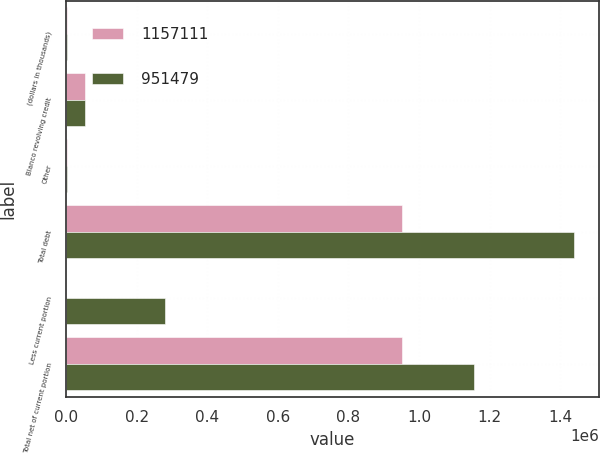<chart> <loc_0><loc_0><loc_500><loc_500><stacked_bar_chart><ecel><fcel>(dollars in thousands)<fcel>Blanco revolving credit<fcel>Other<fcel>Total debt<fcel>Less current portion<fcel>Total net of current portion<nl><fcel>1.15711e+06<fcel>2005<fcel>55000<fcel>2193<fcel>952711<fcel>1232<fcel>951479<nl><fcel>951479<fcel>2004<fcel>55000<fcel>3532<fcel>1.43847e+06<fcel>281360<fcel>1.15711e+06<nl></chart> 